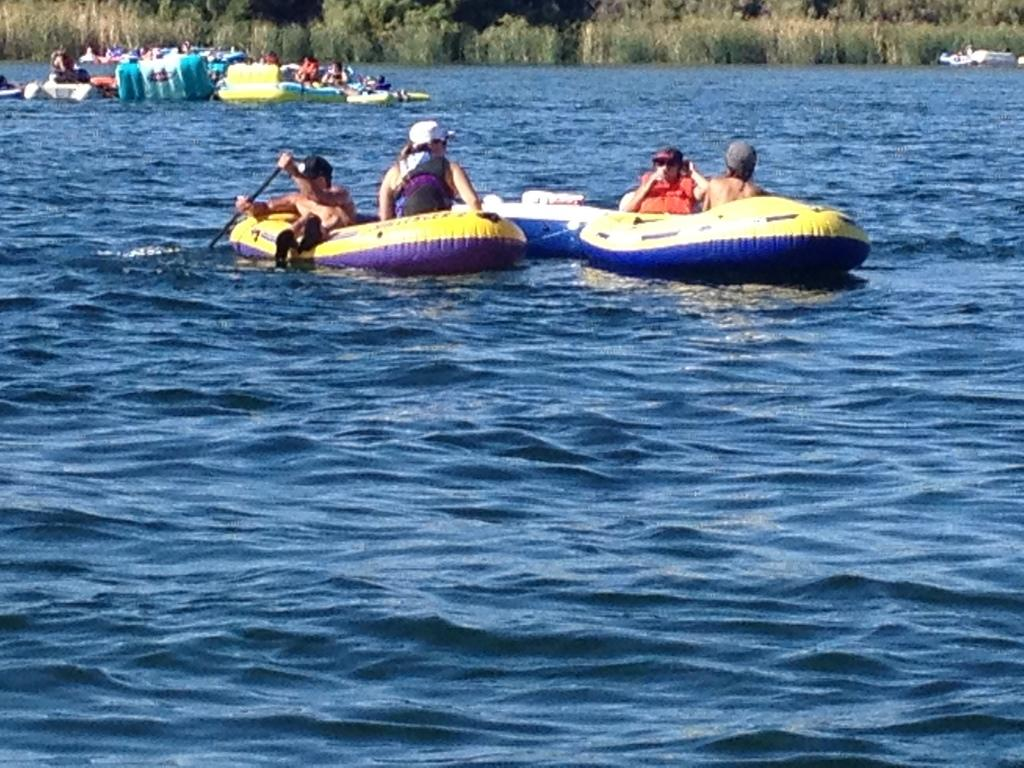What are the people in the image doing? People are rowing boats in the image. Where are the boats located? The boats are on the water. What else can be seen in the image besides the boats and people? There are plants visible in the image. What type of pan can be seen in the image? There is no pan present in the image. What kind of arch can be seen in the image? There is no arch present in the image. 